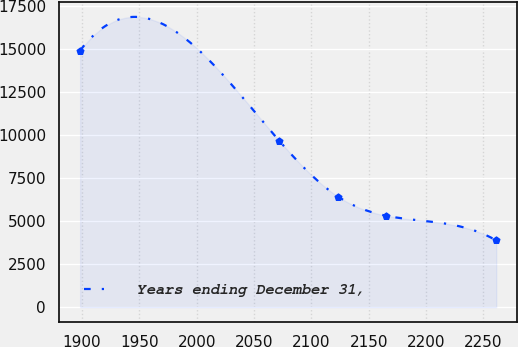<chart> <loc_0><loc_0><loc_500><loc_500><line_chart><ecel><fcel>Years ending December 31,<nl><fcel>1898.4<fcel>14892.7<nl><fcel>2071.86<fcel>9666.26<nl><fcel>2123.45<fcel>6408.35<nl><fcel>2165.33<fcel>5306.62<nl><fcel>2261.19<fcel>3875.4<nl></chart> 